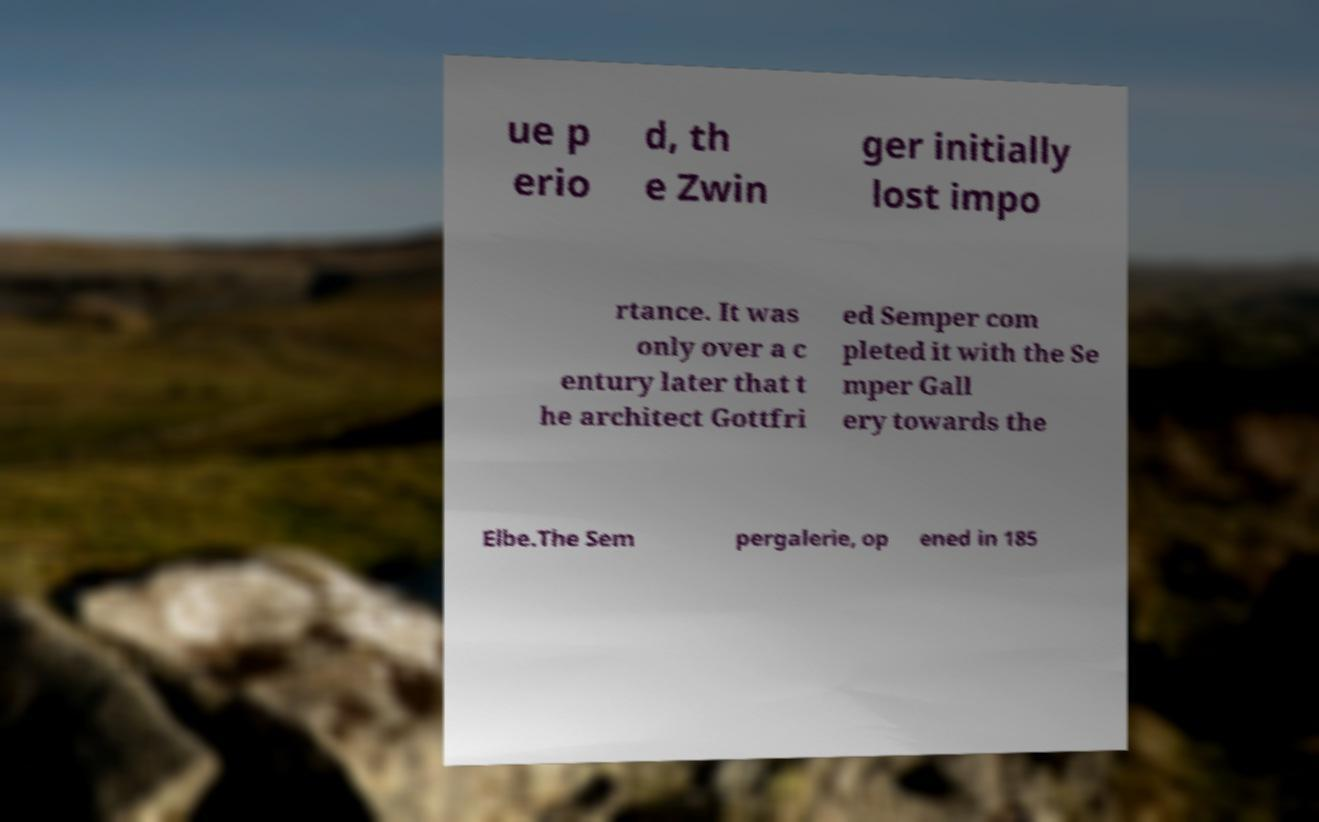Please read and relay the text visible in this image. What does it say? ue p erio d, th e Zwin ger initially lost impo rtance. It was only over a c entury later that t he architect Gottfri ed Semper com pleted it with the Se mper Gall ery towards the Elbe.The Sem pergalerie, op ened in 185 